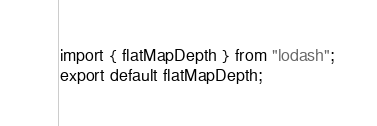<code> <loc_0><loc_0><loc_500><loc_500><_TypeScript_>import { flatMapDepth } from "lodash";
export default flatMapDepth;
</code> 